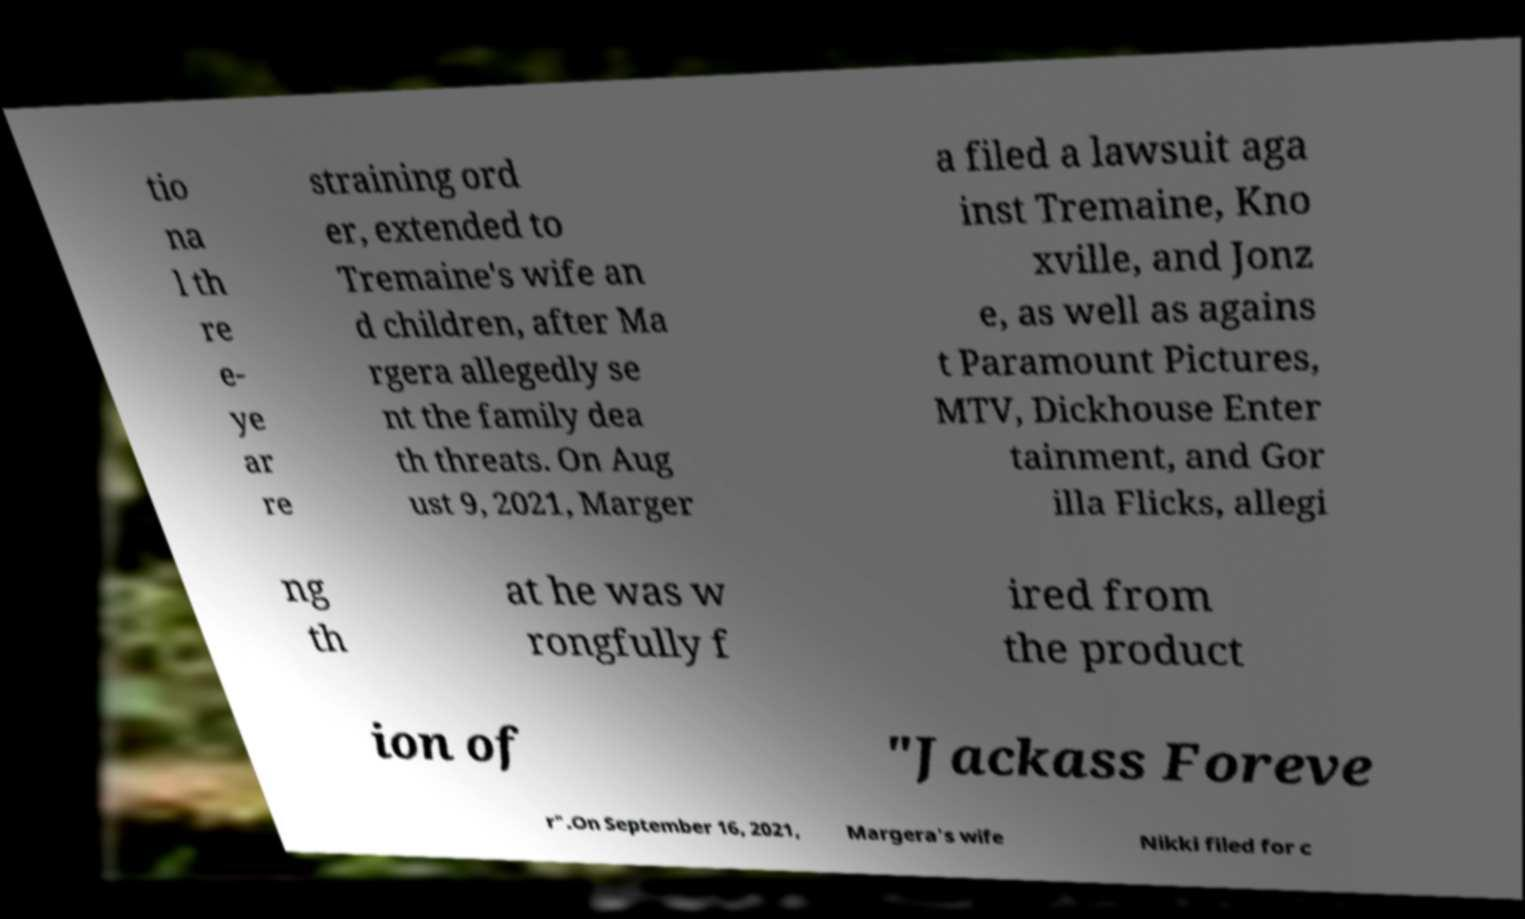Please identify and transcribe the text found in this image. tio na l th re e- ye ar re straining ord er, extended to Tremaine's wife an d children, after Ma rgera allegedly se nt the family dea th threats. On Aug ust 9, 2021, Marger a filed a lawsuit aga inst Tremaine, Kno xville, and Jonz e, as well as agains t Paramount Pictures, MTV, Dickhouse Enter tainment, and Gor illa Flicks, allegi ng th at he was w rongfully f ired from the product ion of "Jackass Foreve r".On September 16, 2021, Margera's wife Nikki filed for c 